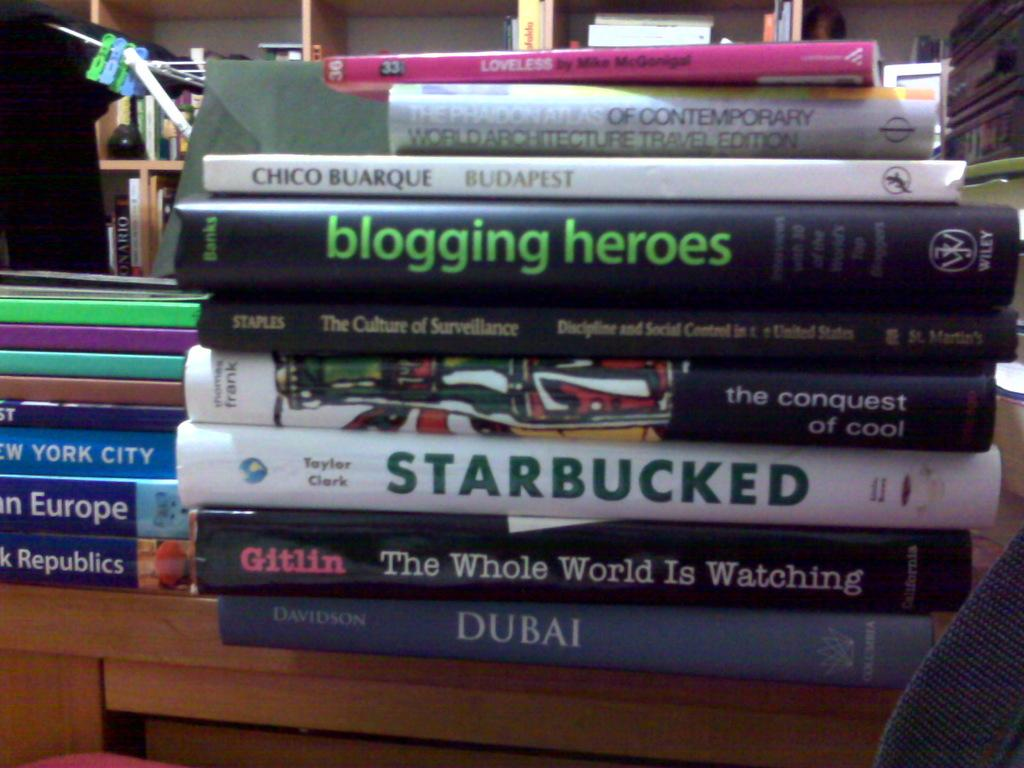<image>
Provide a brief description of the given image. A book titled Starbucked is in a stack of books. 